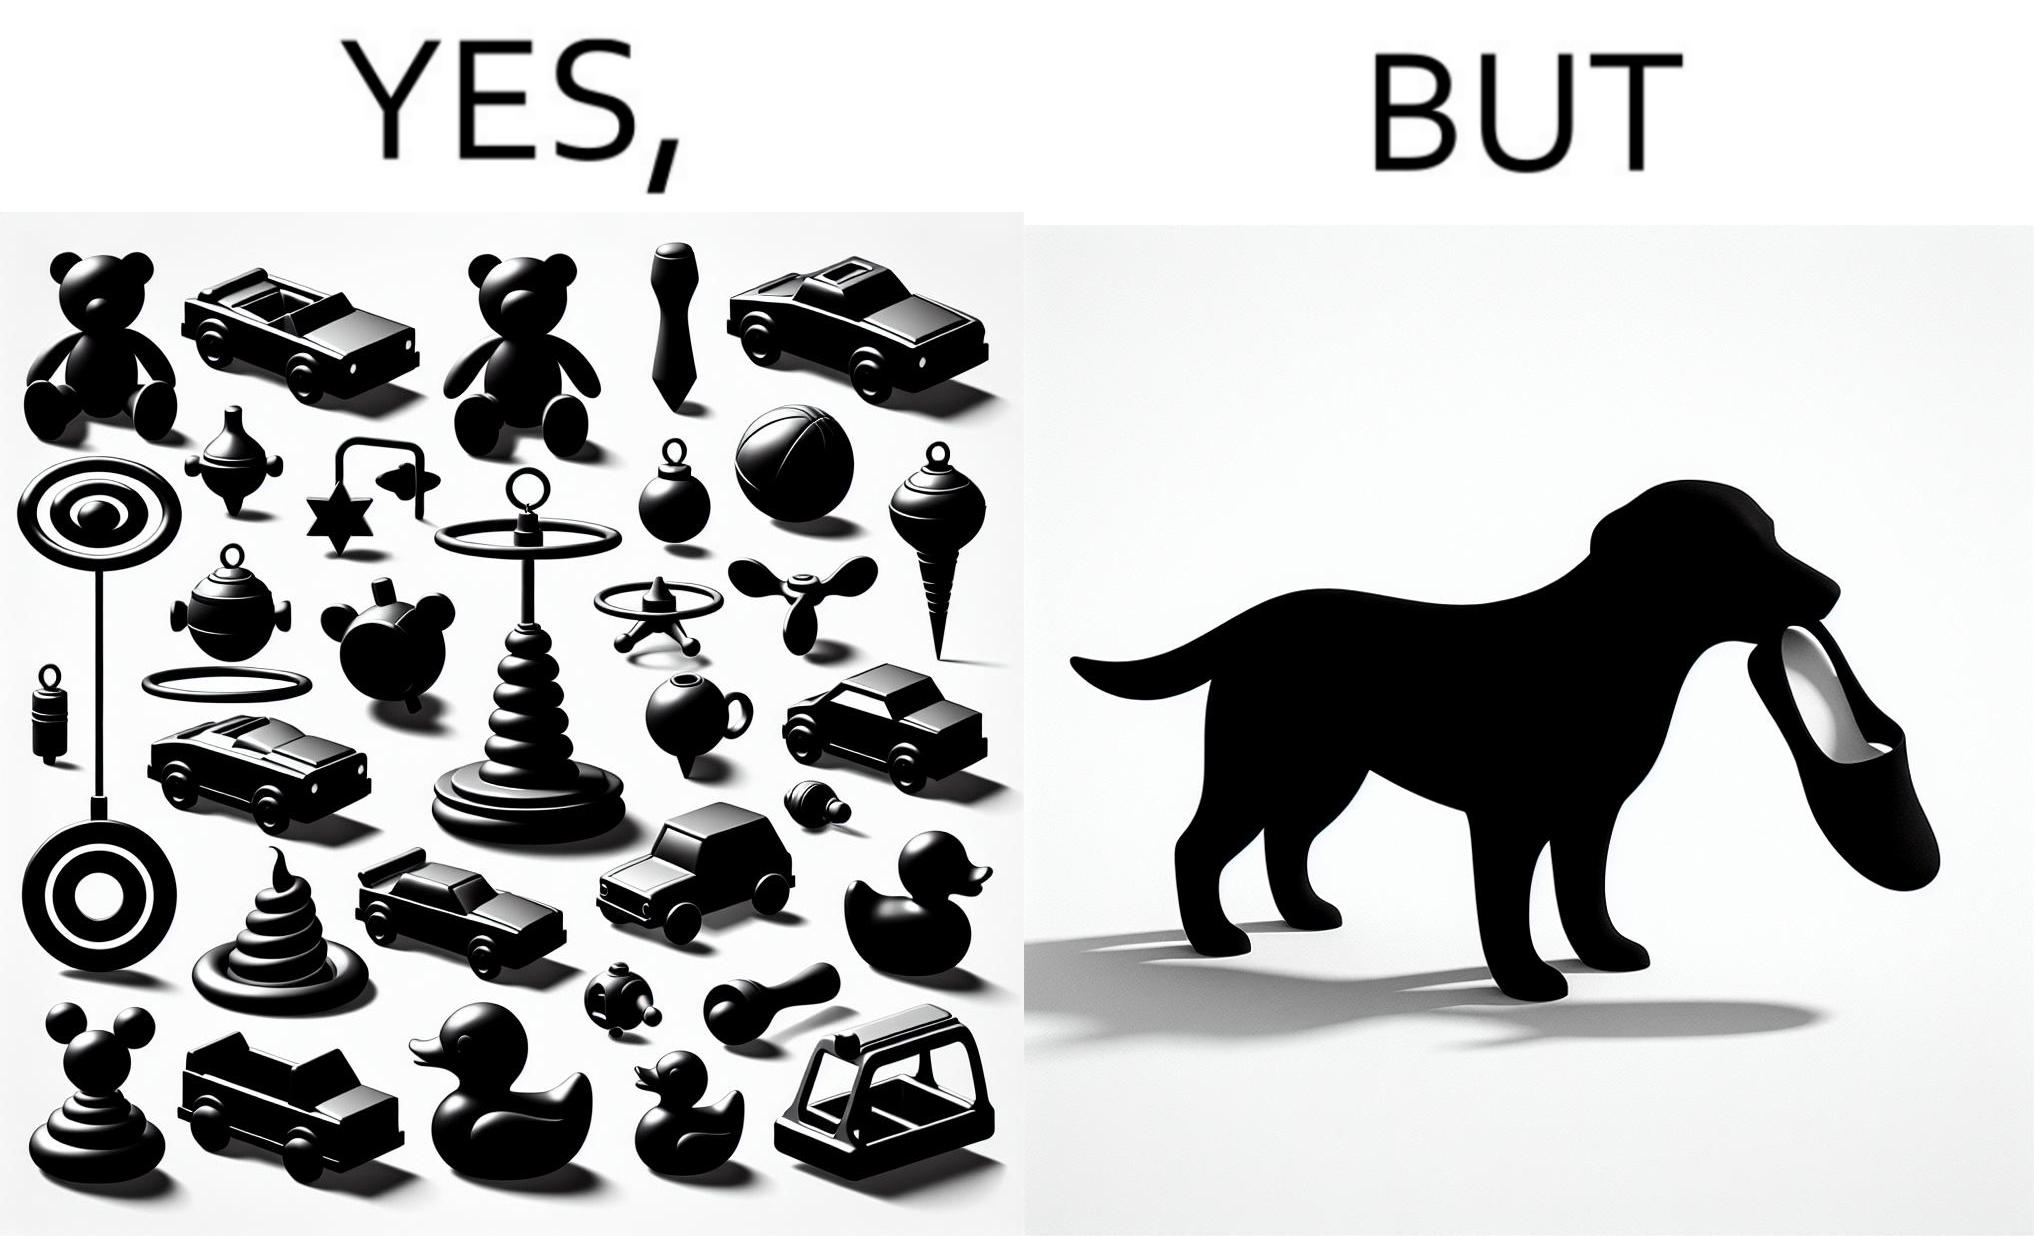What do you see in each half of this image? In the left part of the image: a bunch of toys In the right part of the image: a dog holding a slipper 